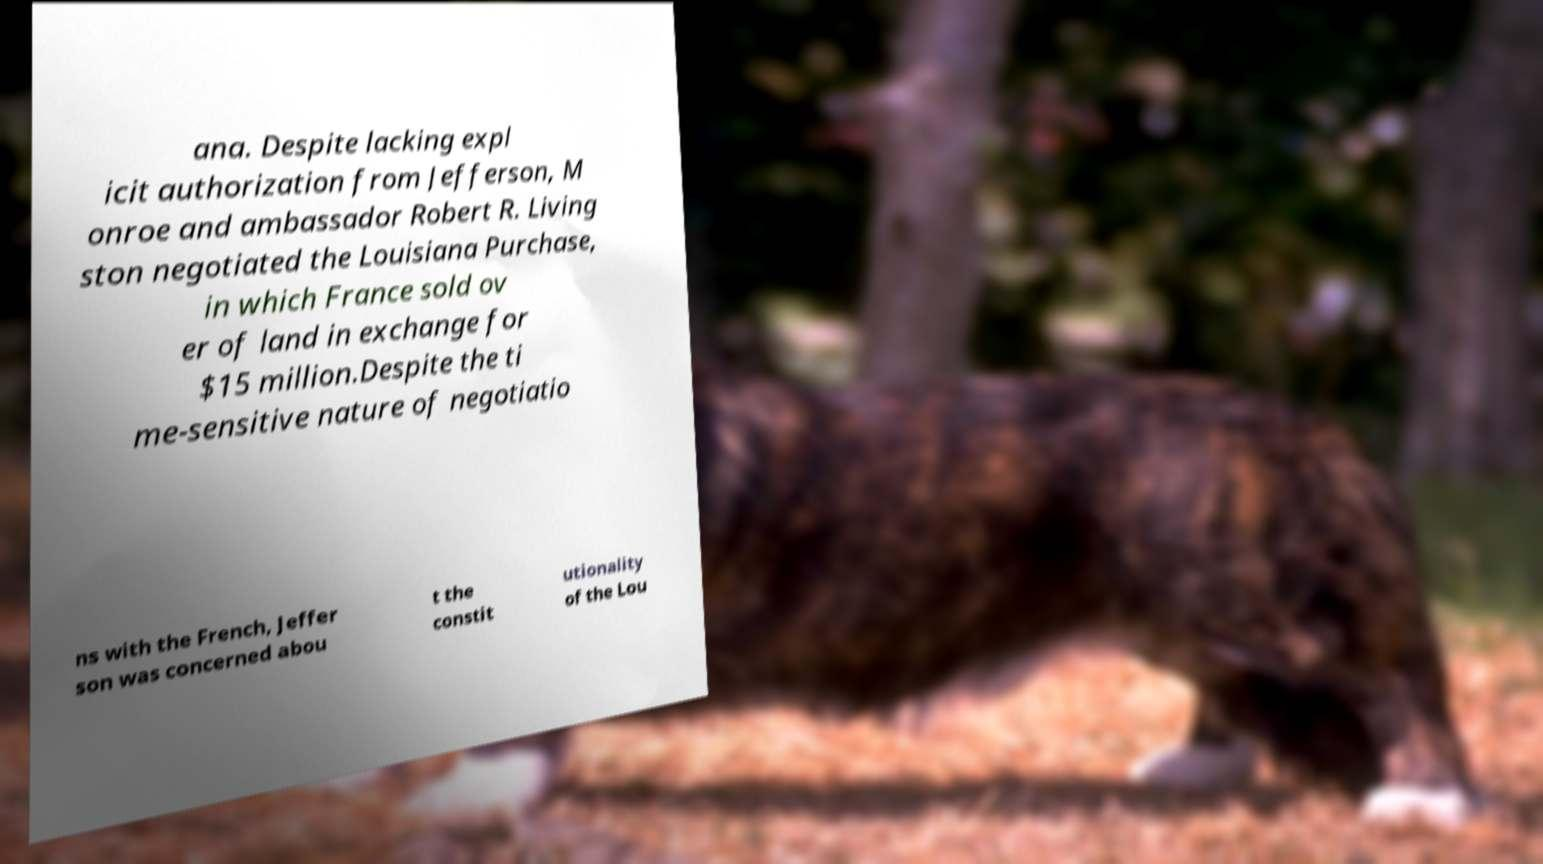Could you extract and type out the text from this image? ana. Despite lacking expl icit authorization from Jefferson, M onroe and ambassador Robert R. Living ston negotiated the Louisiana Purchase, in which France sold ov er of land in exchange for $15 million.Despite the ti me-sensitive nature of negotiatio ns with the French, Jeffer son was concerned abou t the constit utionality of the Lou 